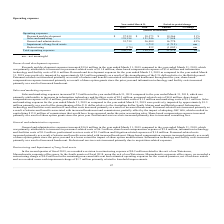According to Mimecast Limited's financial document, What was the increase in the General and administrative expenses in 2019? According to the financial document, $16.8 million. The relevant text states: "General and administrative expenses increased $16.8 million in the year ended March 31, 2019 compared to the year ended March 31, 2018, which..." Also, What caused the share-based compensation expense to increase? primarily as a result of share option grants since the prior year and to a lesser extent the impact of share option modifications.. The document states: "dcount. Share-based compensation expense increased primarily as a result of share option grants since the prior year and to a lesser extent the impact..." Also, What was the Research and development expense in 2019 and 2018 respectively? The document shows two values: $57,939 and $38,373 (in thousands). From the document: "Research and development $ 57,939 $ 38,373 $ 19,566 51% Research and development $ 57,939 $ 38,373 $ 19,566 51%..." Also, can you calculate: What was the average Sales and marketing expense for 2018 and 2019? Based on the calculation: 139,194 - 121,246, the result is 17948 (in thousands). This is based on the information: "Sales and marketing 139,194 121,246 17,948 15% Sales and marketing 139,194 121,246 17,948 15%..." The key data points involved are: 121,246, 139,194. Also, can you calculate: What percentage of total operating expenses was General and administrative in 2019? Based on the calculation: 53,759 / 250,722, the result is 21.44 (percentage). This is based on the information: "General and administrative 53,759 36,989 16,770 45% Total operating expenses $ 250,722 $ 199,152 $ 51,570 26%..." The key data points involved are: 250,722, 53,759. Additionally, In which year was Total operating expenses less than 200,000 thousands? According to the financial document, 2018. The relevant text states: "2019 2018 Amount % Change..." 